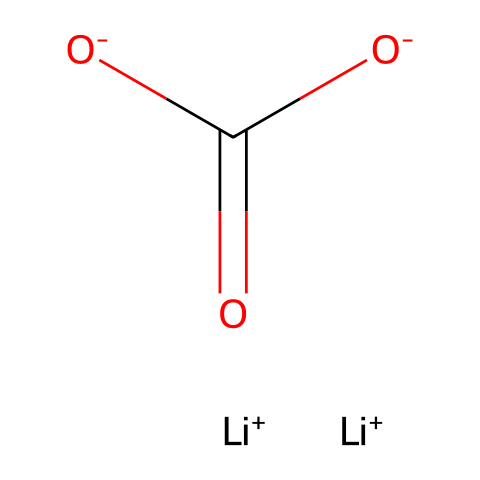What is the total number of lithium atoms in this chemical? The SMILES notation indicates two lithium ions ([Li+]), which means there are two lithium atoms present in the chemical structure.
Answer: 2 How many oxygen atoms are present in this chemical? From the SMILES representation, there are two oxygen atoms shown as [O-] and as part of the carbonate group (C(=O)). Therefore, the total number of oxygen atoms is two.
Answer: 3 What type of bond exists between the carbon atom and the two oxygen atoms in the carbonate group? The structure shows that one of the oxygen atoms is double bonded to the carbon atom, indicated by the "C(=O)," and the other is single bonded, so there is a double bond present.
Answer: double bond What role do lithium ions play in the solubility of lithium carbonate? Lithium ions, being positively charged, help stabilize the negative charge from the carbonate ions, enhancing the solubility of lithium carbonate in water due to the ionic nature of the compound.
Answer: stabilize solubility Is this chemical a strong or weak electrolyte? Lithium carbonate dissociates into its ions in solution, providing an electrical conductivity characteristic of strong electrolytes; therefore, it is considered a strong electrolyte.
Answer: strong What can be inferred about the mood-stabilizing properties of lithium carbonate based on its ionic nature? The ionic nature of lithium carbonate allows it to interact with neural pathways effectively, facilitating mood stabilization by modulating neurotransmitter release, which is essential for its therapeutic use.
Answer: facilitates modulation 